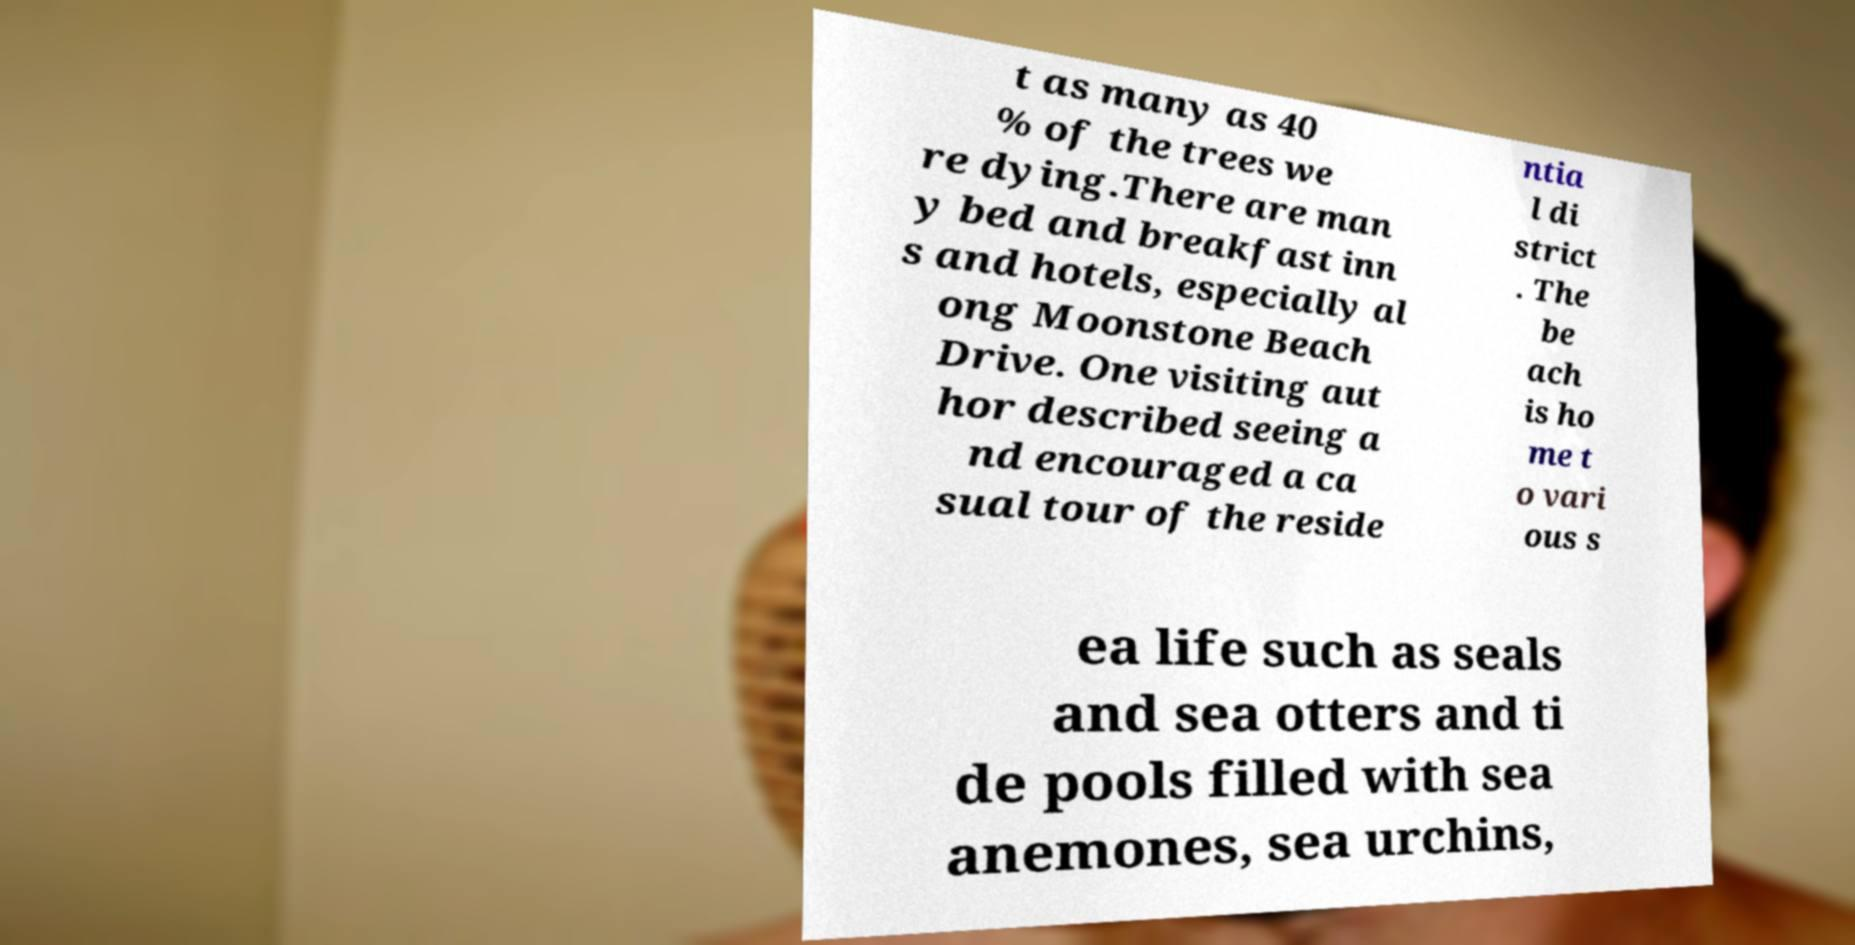There's text embedded in this image that I need extracted. Can you transcribe it verbatim? t as many as 40 % of the trees we re dying.There are man y bed and breakfast inn s and hotels, especially al ong Moonstone Beach Drive. One visiting aut hor described seeing a nd encouraged a ca sual tour of the reside ntia l di strict . The be ach is ho me t o vari ous s ea life such as seals and sea otters and ti de pools filled with sea anemones, sea urchins, 